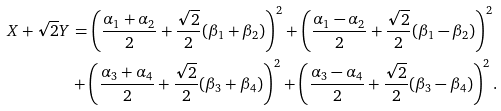<formula> <loc_0><loc_0><loc_500><loc_500>X + \sqrt { 2 } Y & = \left ( \frac { \alpha _ { 1 } + \alpha _ { 2 } } { 2 } + \frac { \sqrt { 2 } } { 2 } ( \beta _ { 1 } + \beta _ { 2 } ) \right ) ^ { 2 } + \left ( \frac { \alpha _ { 1 } - \alpha _ { 2 } } { 2 } + \frac { \sqrt { 2 } } { 2 } ( \beta _ { 1 } - \beta _ { 2 } ) \right ) ^ { 2 } \\ & + \left ( \frac { \alpha _ { 3 } + \alpha _ { 4 } } { 2 } + \frac { \sqrt { 2 } } { 2 } ( \beta _ { 3 } + \beta _ { 4 } ) \right ) ^ { 2 } + \left ( \frac { \alpha _ { 3 } - \alpha _ { 4 } } { 2 } + \frac { \sqrt { 2 } } { 2 } ( \beta _ { 3 } - \beta _ { 4 } ) \right ) ^ { 2 } .</formula> 